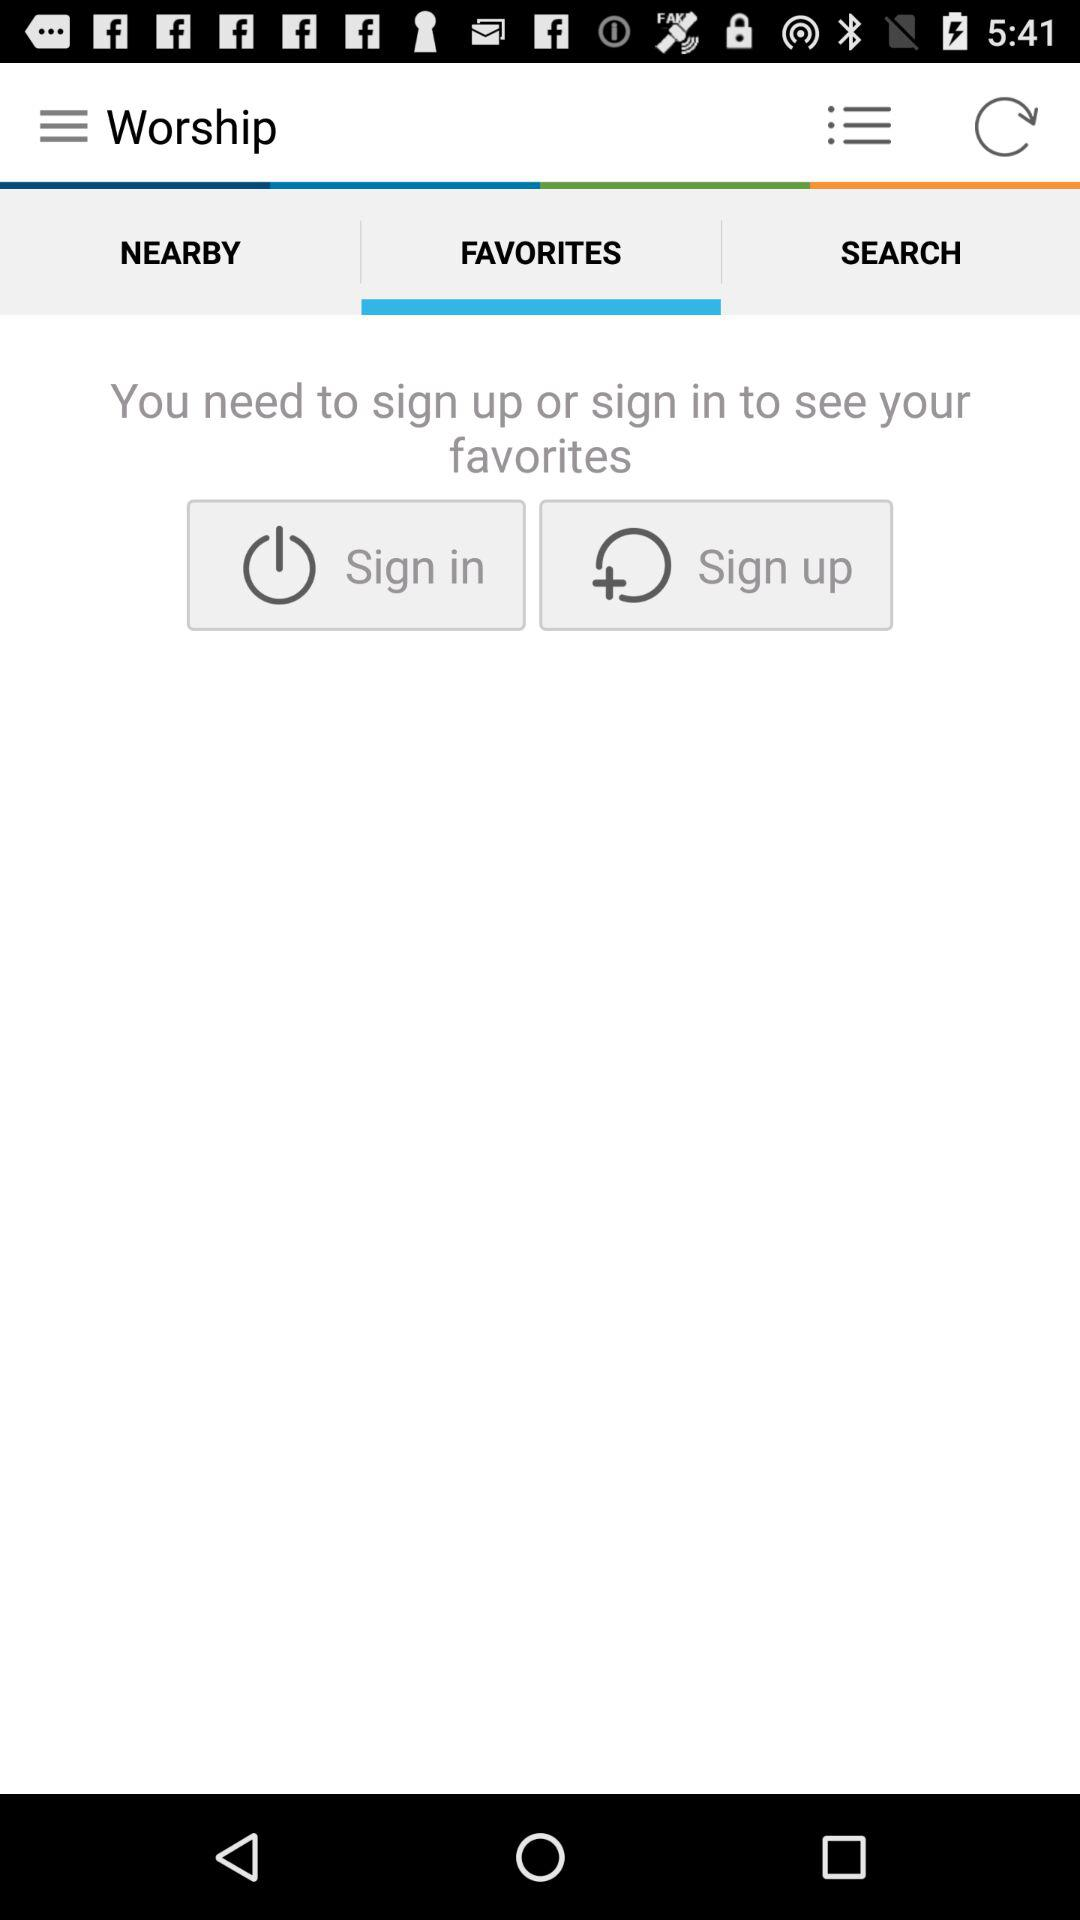How can favorites be seen? Favorites can be seen by signing up or signing in. 